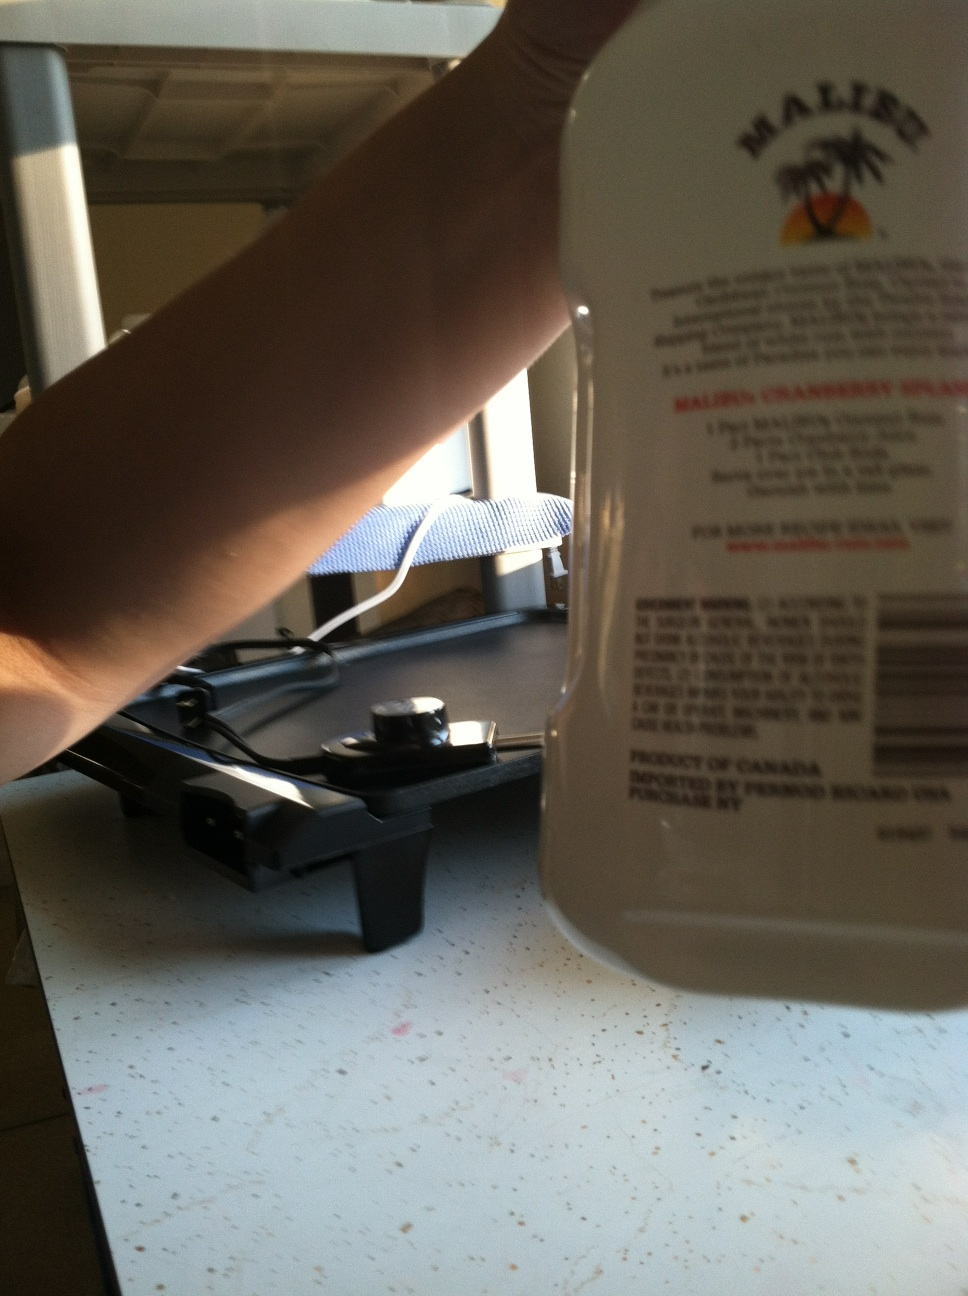What is this? This is a bottle of Malibu Cranberry Splash, a flavored liqueur, as indicated by the label visible in the image. 